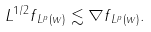<formula> <loc_0><loc_0><loc_500><loc_500>\| L ^ { 1 / 2 } f \| _ { L ^ { p } ( w ) } \lesssim \| \nabla f \| _ { L ^ { p } ( w ) } .</formula> 